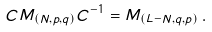Convert formula to latex. <formula><loc_0><loc_0><loc_500><loc_500>C M _ { ( N , p , q ) } C ^ { - 1 } = M _ { ( L - N , q , p ) } \, .</formula> 